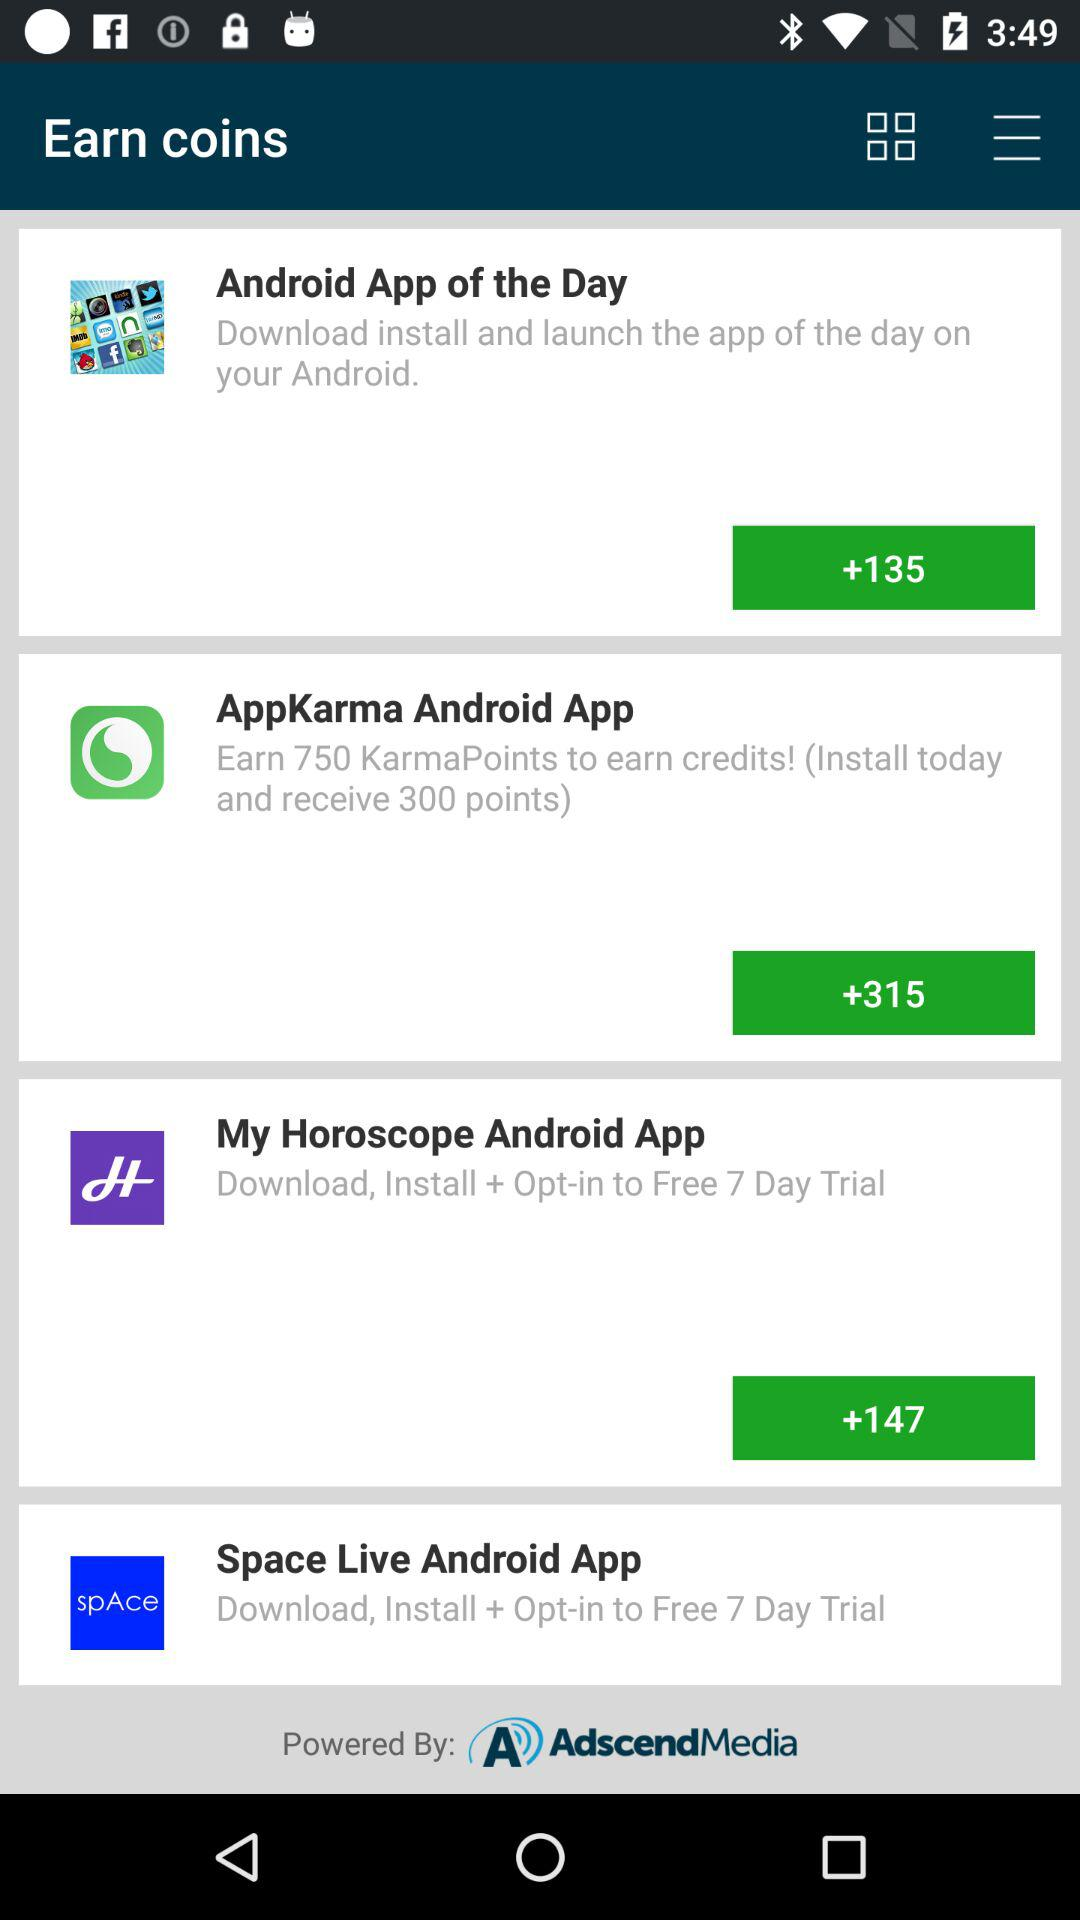How many Android apps are promoted on this screen?
Answer the question using a single word or phrase. 4 